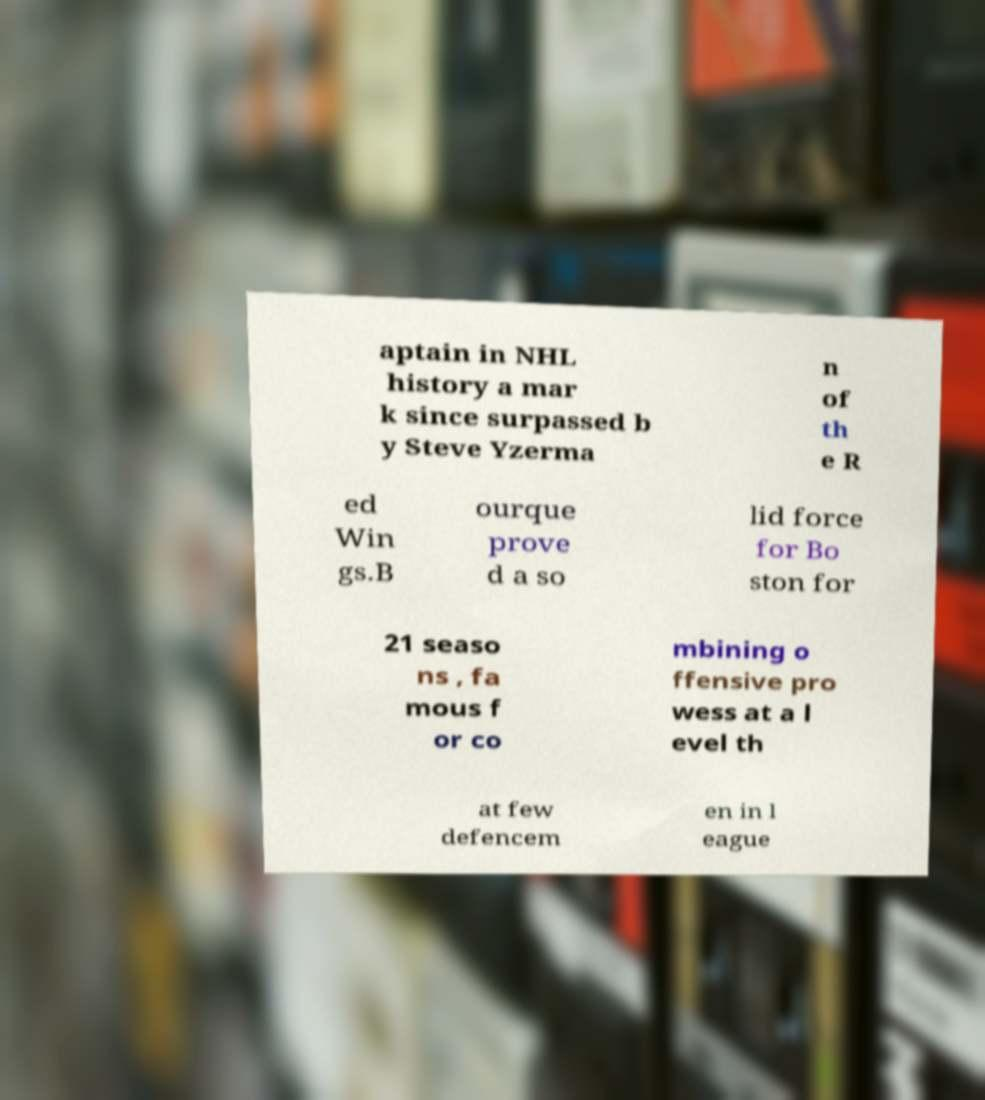Could you extract and type out the text from this image? aptain in NHL history a mar k since surpassed b y Steve Yzerma n of th e R ed Win gs.B ourque prove d a so lid force for Bo ston for 21 seaso ns , fa mous f or co mbining o ffensive pro wess at a l evel th at few defencem en in l eague 